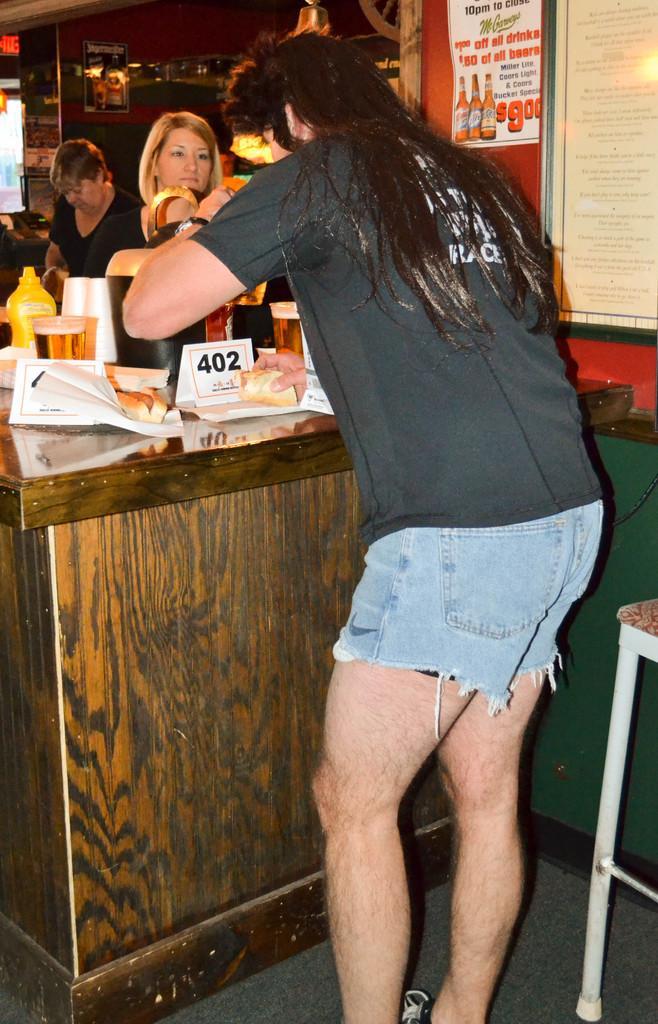In one or two sentences, can you explain what this image depicts? In this image there is a person standing and at the background of the image there are two lady persons standing behind a wooden block. 